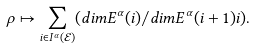Convert formula to latex. <formula><loc_0><loc_0><loc_500><loc_500>\rho \mapsto \sum _ { i \in I ^ { \alpha } ( \mathcal { E } ) } ( d i m E ^ { \alpha } ( i ) / d i m E ^ { \alpha } ( i + 1 ) i ) .</formula> 